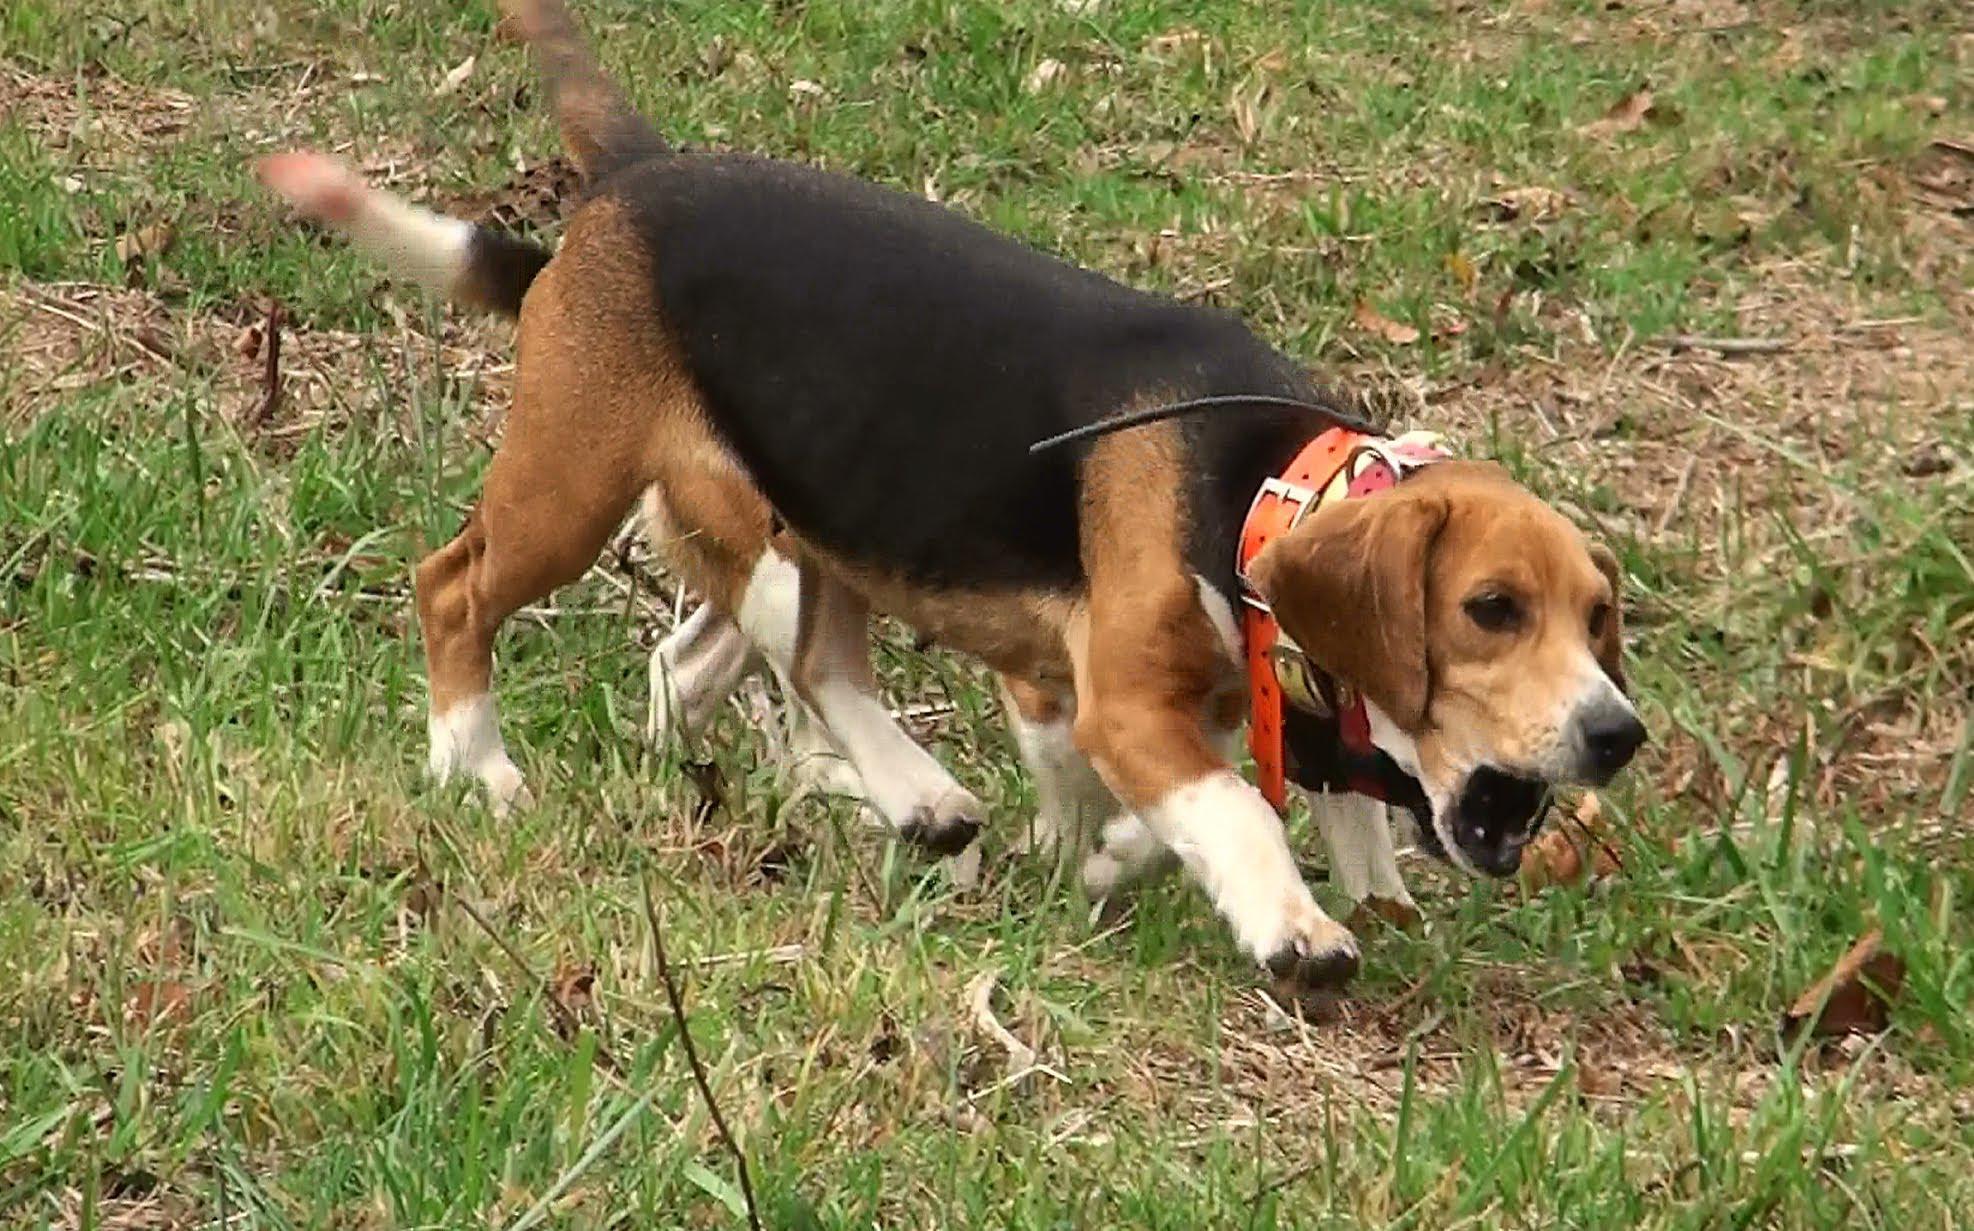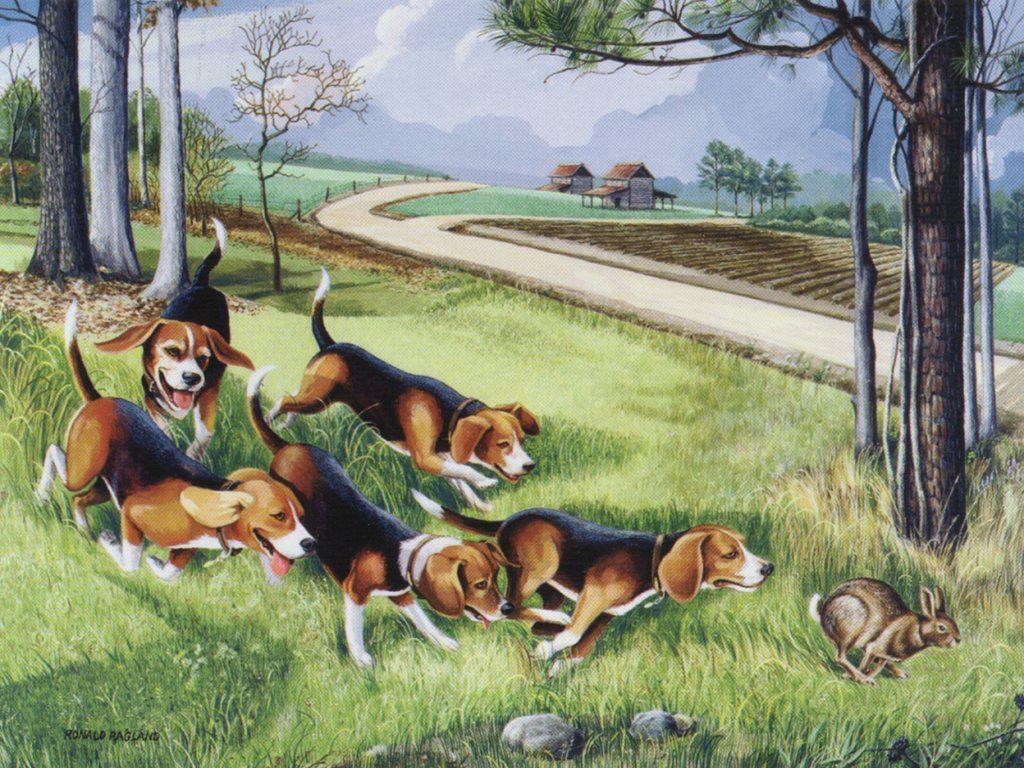The first image is the image on the left, the second image is the image on the right. Assess this claim about the two images: "An image shows multiple men in blazers, caps and tall socks over pants standing near a pack of hounds.". Correct or not? Answer yes or no. No. The first image is the image on the left, the second image is the image on the right. Considering the images on both sides, is "A single man poses with at least one dog in the image on the left." valid? Answer yes or no. No. 